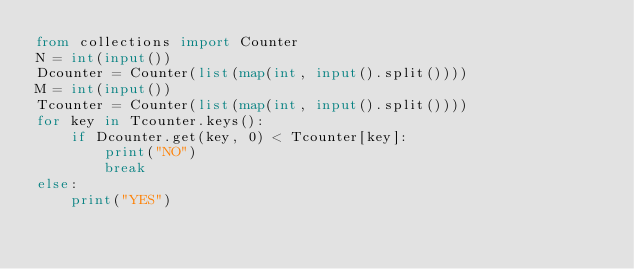<code> <loc_0><loc_0><loc_500><loc_500><_Python_>from collections import Counter
N = int(input())
Dcounter = Counter(list(map(int, input().split())))
M = int(input())
Tcounter = Counter(list(map(int, input().split())))
for key in Tcounter.keys():
    if Dcounter.get(key, 0) < Tcounter[key]:
        print("NO")
        break
else:
    print("YES")
</code> 